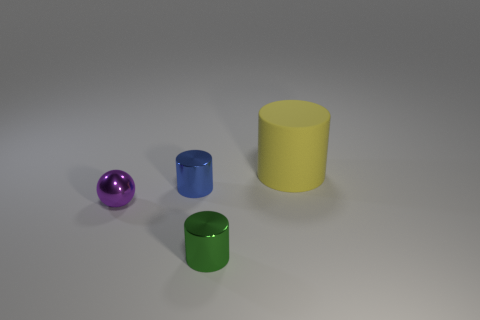What color is the tiny metal object that is to the right of the blue metal cylinder behind the shiny cylinder that is on the right side of the small blue metallic cylinder?
Your answer should be very brief. Green. Are there any other things that have the same shape as the small blue shiny object?
Your response must be concise. Yes. Are there more objects than large cylinders?
Your response must be concise. Yes. How many things are both on the left side of the small green shiny cylinder and to the right of the green metal cylinder?
Give a very brief answer. 0. How many green metal cylinders are left of the small cylinder behind the green metallic thing?
Your response must be concise. 0. Do the metal object in front of the tiny purple ball and the metal cylinder that is behind the ball have the same size?
Keep it short and to the point. Yes. How many things are there?
Ensure brevity in your answer.  4. How many green cylinders have the same material as the large object?
Provide a succinct answer. 0. Are there the same number of large objects right of the yellow rubber thing and small shiny objects?
Offer a terse response. No. There is a yellow cylinder; does it have the same size as the object that is in front of the small purple shiny sphere?
Provide a succinct answer. No. 